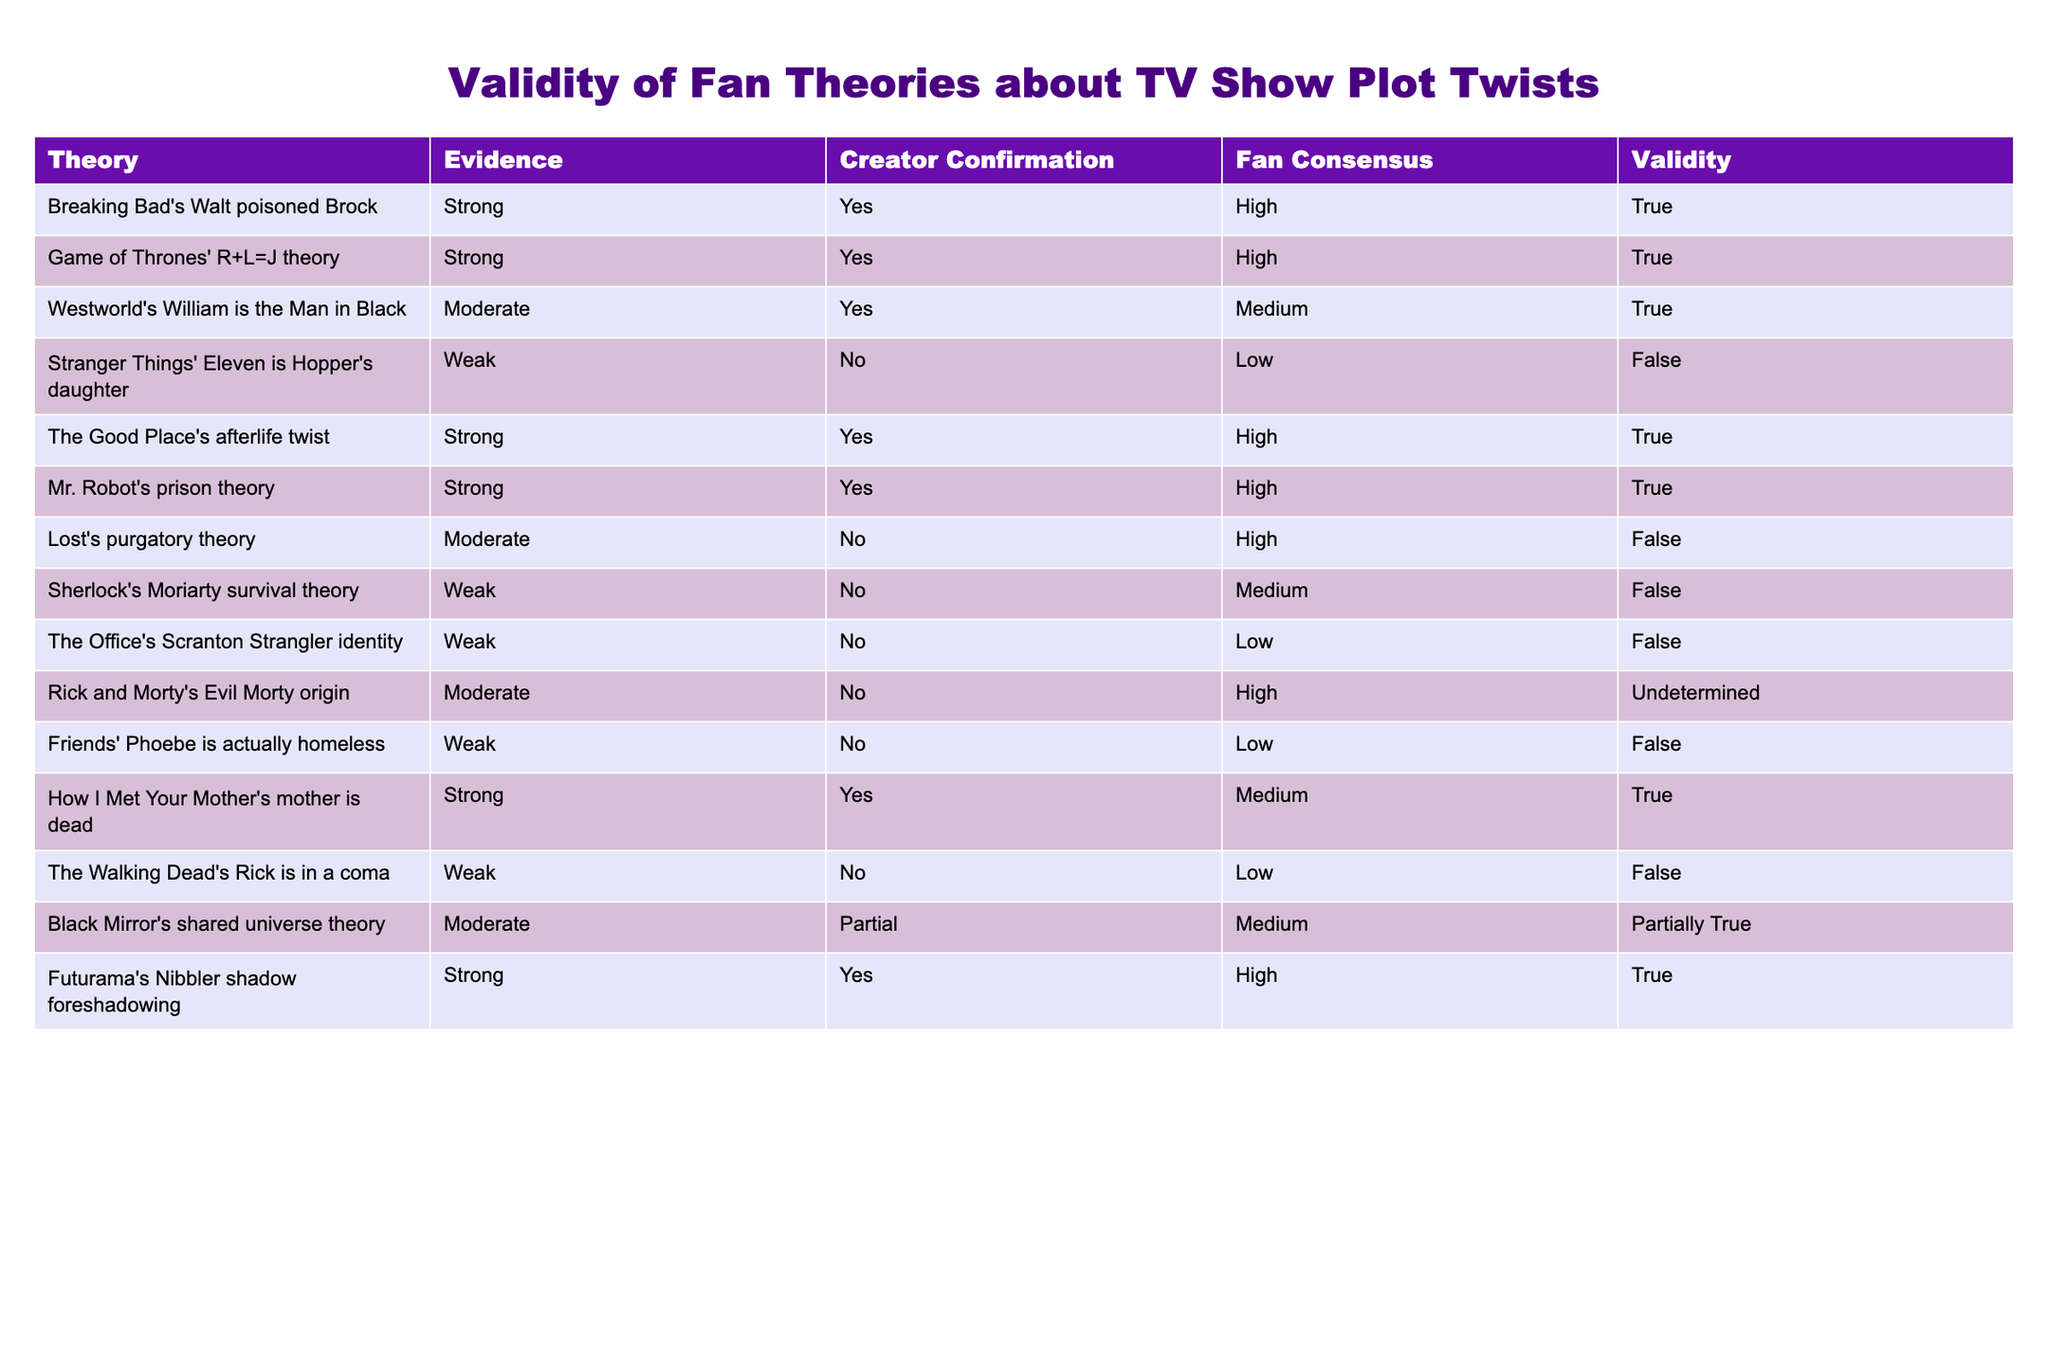What is the validity of the theory that "Sherlock's Moriarty survived"? The validity of a theory is indicated in the last column of the table. Looking at the row for "Sherlock's Moriarty survival theory," it shows a validity of "False."
Answer: False How many theories in the table have "Strong" evidence? By counting the number of theories listed under the "Evidence" column that state "Strong," we find six instances: "Walt poisoned Brock," "R+L=J theory," "The Good Place's afterlife twist," "Mr. Robot's prison theory," "Futurama's Nibbler shadow foreshadowing," and "How I Met Your Mother's mother is dead." This gives a total of six theories with strong evidence.
Answer: 6 Is there a theory about "Lost" that has "High" fan consensus? In reviewing the data, the only entry for "Lost" is "Lost's purgatory theory," which has a fan consensus marked as "High." However, this theory has a validity of "False," which indicates that despite the high consensus, it does not hold true.
Answer: Yes What is the average fan consensus score for theories with "Weak" evidence? We review the theories with "Weak" evidence: "Eleven is Hopper's daughter," "Moriarty survival," "The Office's Scranton Strangler identity," "Phoebe is actually homeless," and "Rick is in a coma," which have fan consensus scores of Low (1), Medium (2), Low (1), Low (1), and Low (1). Counting these gives us a total score of 6. Since there are five theories, the average is 6/5 = 1.2, which can be considered as Low overall.
Answer: Low Which theories have creator confirmation but are not valid? By reviewing the table, we see that the only theory with creator confirmation marked as "Yes" but has a false validity is "Lost's purgatory theory," indicating that even though the creator confirmed it, it is not considered valid by the fans.
Answer: Lost's purgatory theory What percentage of theories are deemed valid according to the table? There are 15 theories listed in total. Out of these, 8 are valid (True or Partially True), which is calculated by (8/15) * 100. This results in approximately 53.33%. Thus, rounding gives us a percentage of about 53%.
Answer: 53% What theory has "Partial" creator confirmation and "Medium" fan consensus? Checking the table, the theory that fits this description is "Black Mirror's shared universe theory," which has "Partial" in the creator confirmation column and "Medium" in the fan consensus column.
Answer: Black Mirror's shared universe theory Which show has the highest number of "True" theories? By analyzing the table, we see that "Breaking Bad," "Game of Thrones," "The Good Place," "Mr. Robot," "Futurama," and "How I Met Your Mother" each have one valid theory marked as True. None of them has a higher count than the rest, making them all equal.
Answer: None, they're equal 